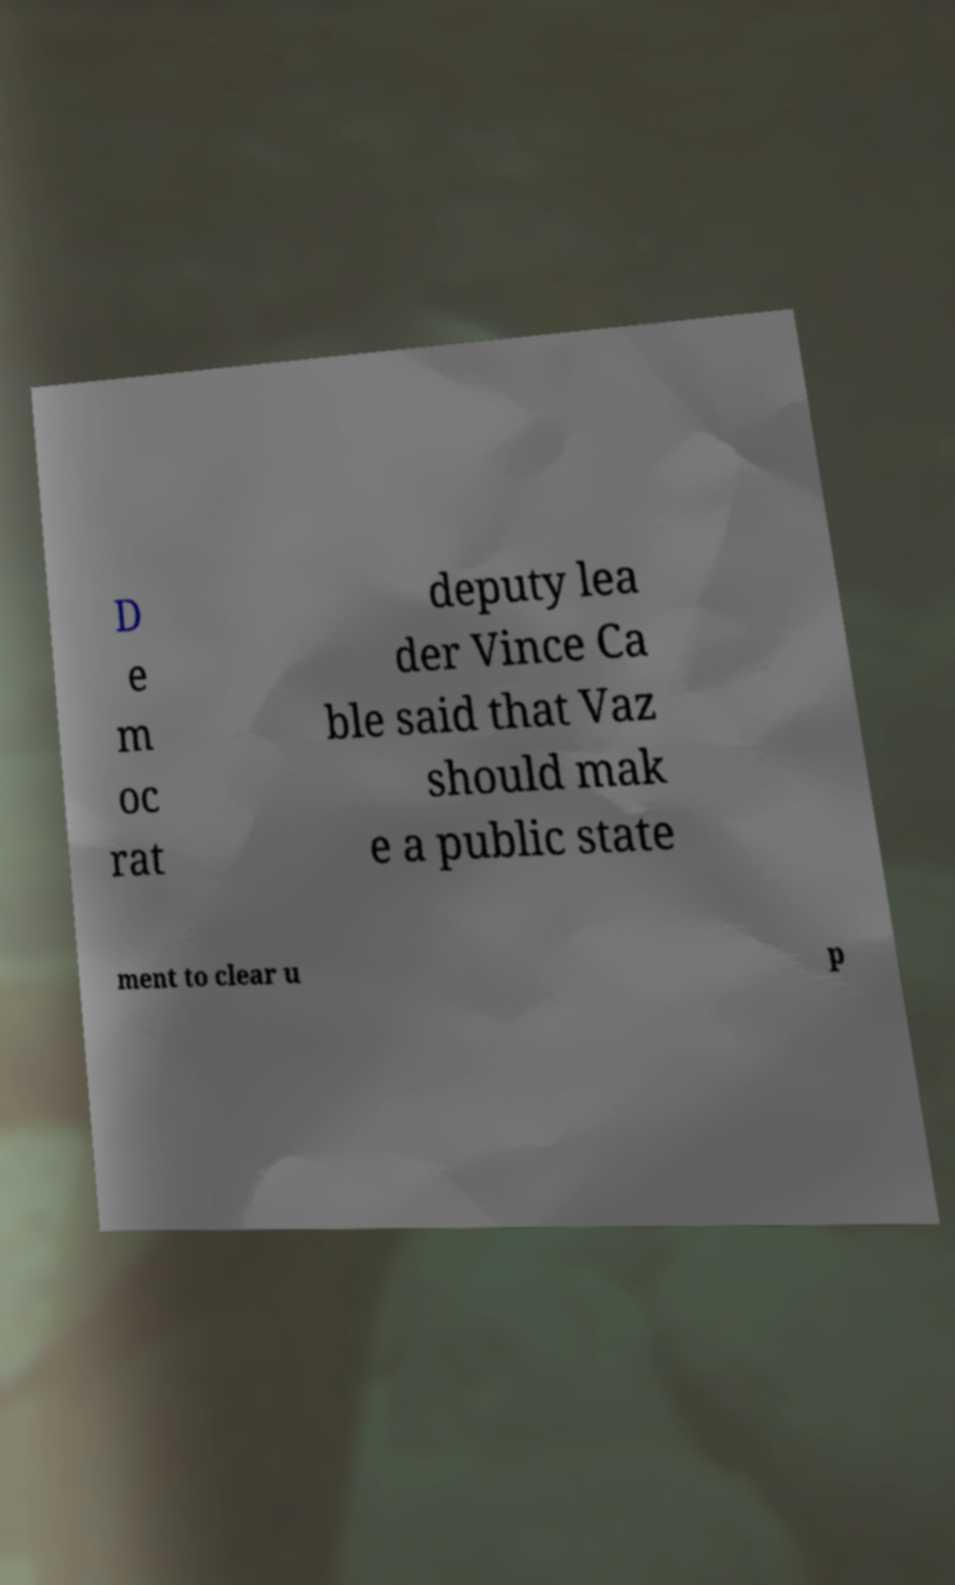Can you read and provide the text displayed in the image?This photo seems to have some interesting text. Can you extract and type it out for me? D e m oc rat deputy lea der Vince Ca ble said that Vaz should mak e a public state ment to clear u p 